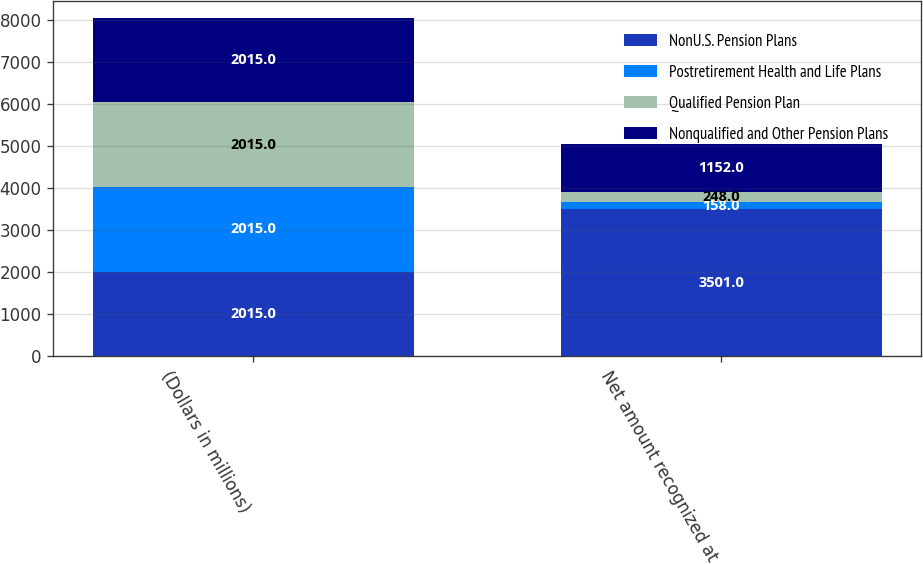Convert chart to OTSL. <chart><loc_0><loc_0><loc_500><loc_500><stacked_bar_chart><ecel><fcel>(Dollars in millions)<fcel>Net amount recognized at<nl><fcel>NonU.S. Pension Plans<fcel>2015<fcel>3501<nl><fcel>Postretirement Health and Life Plans<fcel>2015<fcel>158<nl><fcel>Qualified Pension Plan<fcel>2015<fcel>248<nl><fcel>Nonqualified and Other Pension Plans<fcel>2015<fcel>1152<nl></chart> 